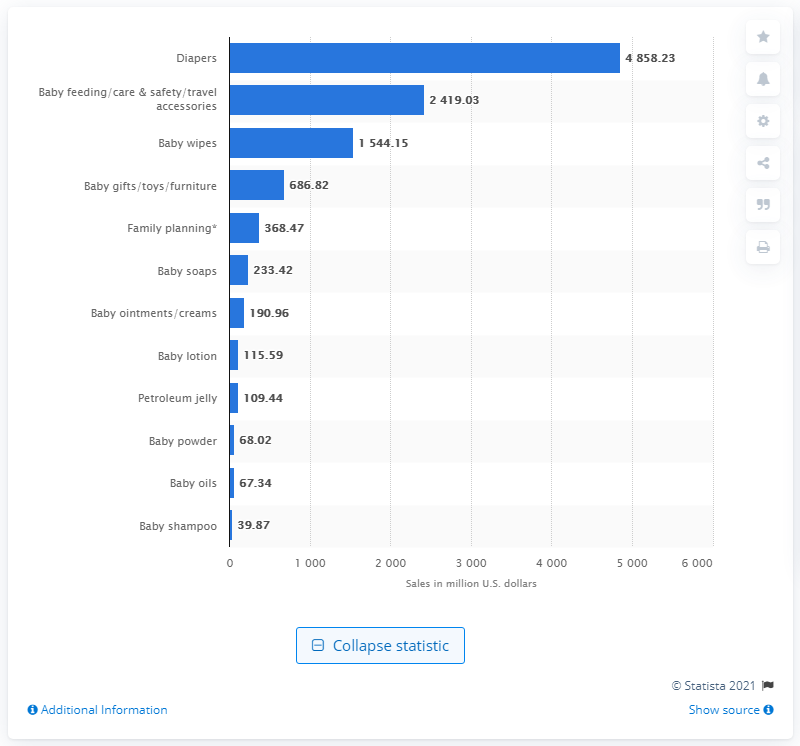Mention a couple of crucial points in this snapshot. The value of baby diapers sold through food, drug, and mass merchandise outlets during the 52 weeks ending October 4, 2020 was $4858.23. 